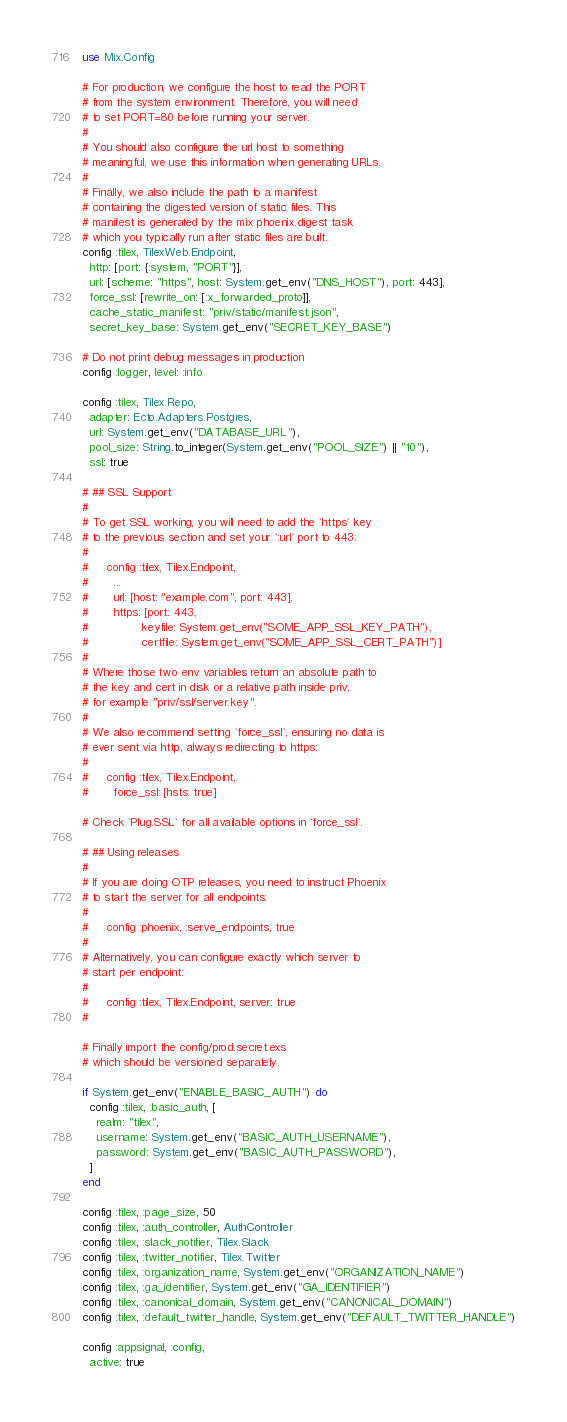Convert code to text. <code><loc_0><loc_0><loc_500><loc_500><_Elixir_>use Mix.Config

# For production, we configure the host to read the PORT
# from the system environment. Therefore, you will need
# to set PORT=80 before running your server.
#
# You should also configure the url host to something
# meaningful, we use this information when generating URLs.
#
# Finally, we also include the path to a manifest
# containing the digested version of static files. This
# manifest is generated by the mix phoenix.digest task
# which you typically run after static files are built.
config :tilex, TilexWeb.Endpoint,
  http: [port: {:system, "PORT"}],
  url: [scheme: "https", host: System.get_env("DNS_HOST"), port: 443],
  force_ssl: [rewrite_on: [:x_forwarded_proto]],
  cache_static_manifest: "priv/static/manifest.json",
  secret_key_base: System.get_env("SECRET_KEY_BASE")

# Do not print debug messages in production
config :logger, level: :info

config :tilex, Tilex.Repo,
  adapter: Ecto.Adapters.Postgres,
  url: System.get_env("DATABASE_URL"),
  pool_size: String.to_integer(System.get_env("POOL_SIZE") || "10"),
  ssl: true

# ## SSL Support
#
# To get SSL working, you will need to add the `https` key
# to the previous section and set your `:url` port to 443:
#
#     config :tilex, Tilex.Endpoint,
#       ...
#       url: [host: "example.com", port: 443],
#       https: [port: 443,
#               keyfile: System.get_env("SOME_APP_SSL_KEY_PATH"),
#               certfile: System.get_env("SOME_APP_SSL_CERT_PATH")]
#
# Where those two env variables return an absolute path to
# the key and cert in disk or a relative path inside priv,
# for example "priv/ssl/server.key".
#
# We also recommend setting `force_ssl`, ensuring no data is
# ever sent via http, always redirecting to https:
#
#     config :tilex, Tilex.Endpoint,
#       force_ssl: [hsts: true]

# Check `Plug.SSL` for all available options in `force_ssl`.

# ## Using releases
#
# If you are doing OTP releases, you need to instruct Phoenix
# to start the server for all endpoints:
#
#     config :phoenix, :serve_endpoints, true
#
# Alternatively, you can configure exactly which server to
# start per endpoint:
#
#     config :tilex, Tilex.Endpoint, server: true
#

# Finally import the config/prod.secret.exs
# which should be versioned separately.

if System.get_env("ENABLE_BASIC_AUTH") do
  config :tilex, :basic_auth, [
    realm: "tilex",
    username: System.get_env("BASIC_AUTH_USERNAME"),
    password: System.get_env("BASIC_AUTH_PASSWORD"),
  ]
end

config :tilex, :page_size, 50
config :tilex, :auth_controller, AuthController
config :tilex, :slack_notifier, Tilex.Slack
config :tilex, :twitter_notifier, Tilex.Twitter
config :tilex, :organization_name, System.get_env("ORGANIZATION_NAME")
config :tilex, :ga_identifier, System.get_env("GA_IDENTIFIER")
config :tilex, :canonical_domain, System.get_env("CANONICAL_DOMAIN")
config :tilex, :default_twitter_handle, System.get_env("DEFAULT_TWITTER_HANDLE")

config :appsignal, :config,
  active: true
</code> 